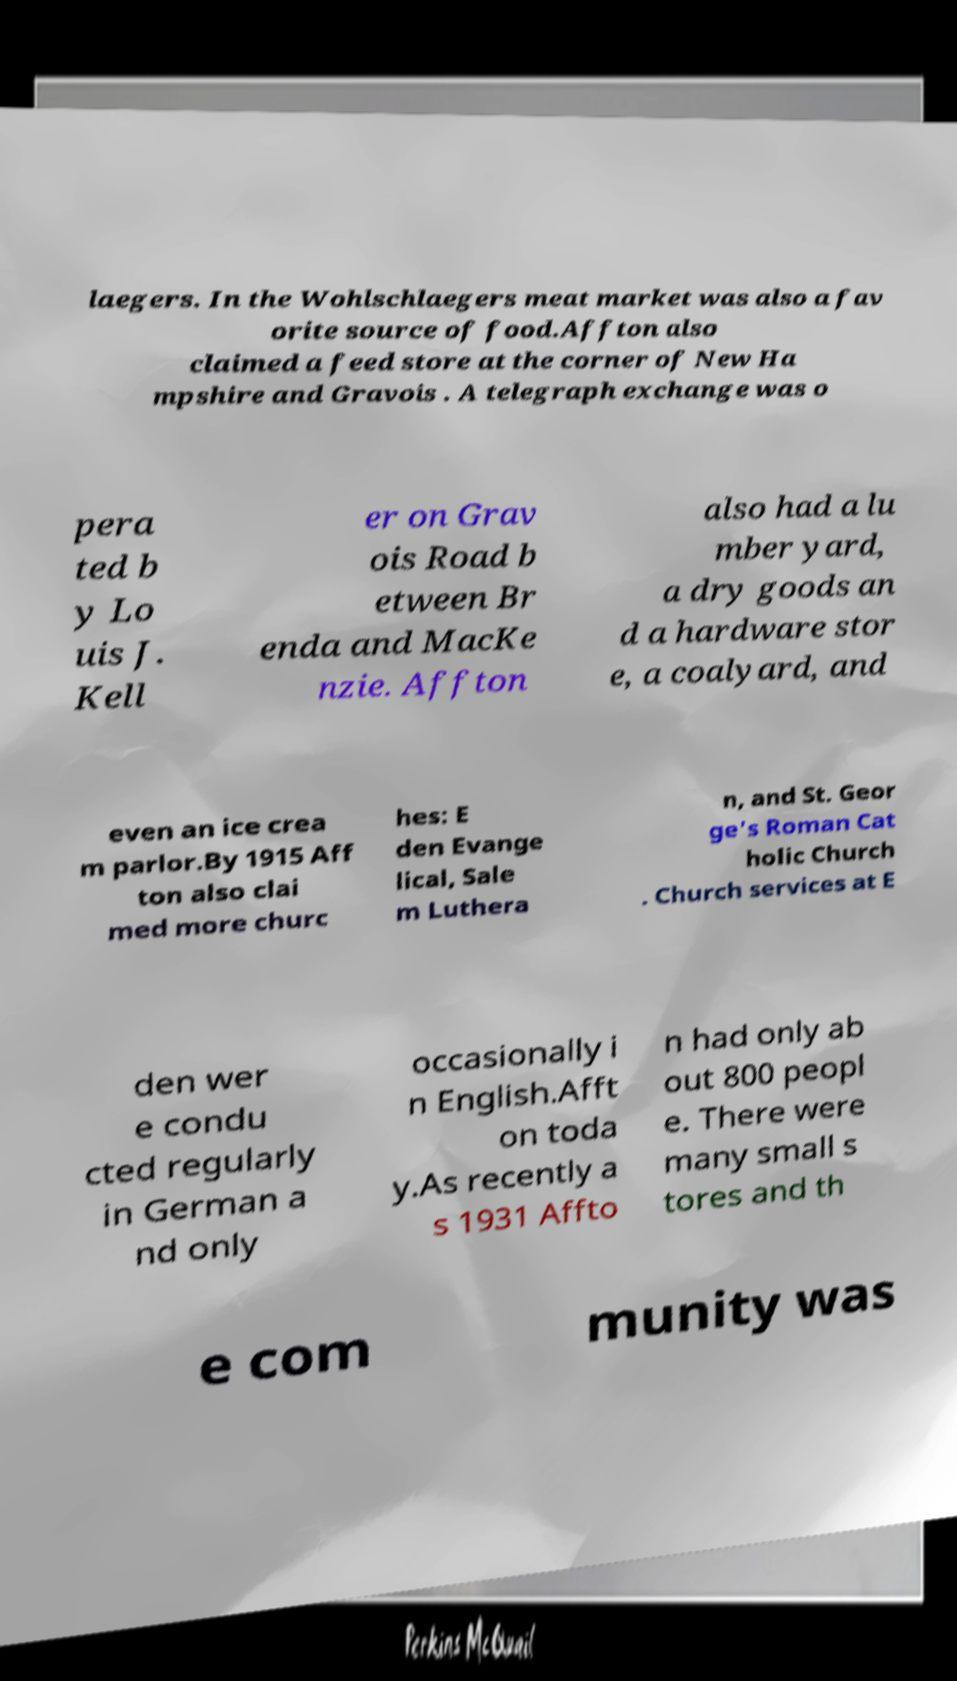Could you extract and type out the text from this image? laegers. In the Wohlschlaegers meat market was also a fav orite source of food.Affton also claimed a feed store at the corner of New Ha mpshire and Gravois . A telegraph exchange was o pera ted b y Lo uis J. Kell er on Grav ois Road b etween Br enda and MacKe nzie. Affton also had a lu mber yard, a dry goods an d a hardware stor e, a coalyard, and even an ice crea m parlor.By 1915 Aff ton also clai med more churc hes: E den Evange lical, Sale m Luthera n, and St. Geor ge's Roman Cat holic Church . Church services at E den wer e condu cted regularly in German a nd only occasionally i n English.Afft on toda y.As recently a s 1931 Affto n had only ab out 800 peopl e. There were many small s tores and th e com munity was 